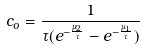Convert formula to latex. <formula><loc_0><loc_0><loc_500><loc_500>c _ { o } = \frac { 1 } { \tau ( e ^ { - \frac { \mu _ { 2 } } { \tau } } - e ^ { - \frac { \mu _ { 1 } } { \tau } } ) }</formula> 